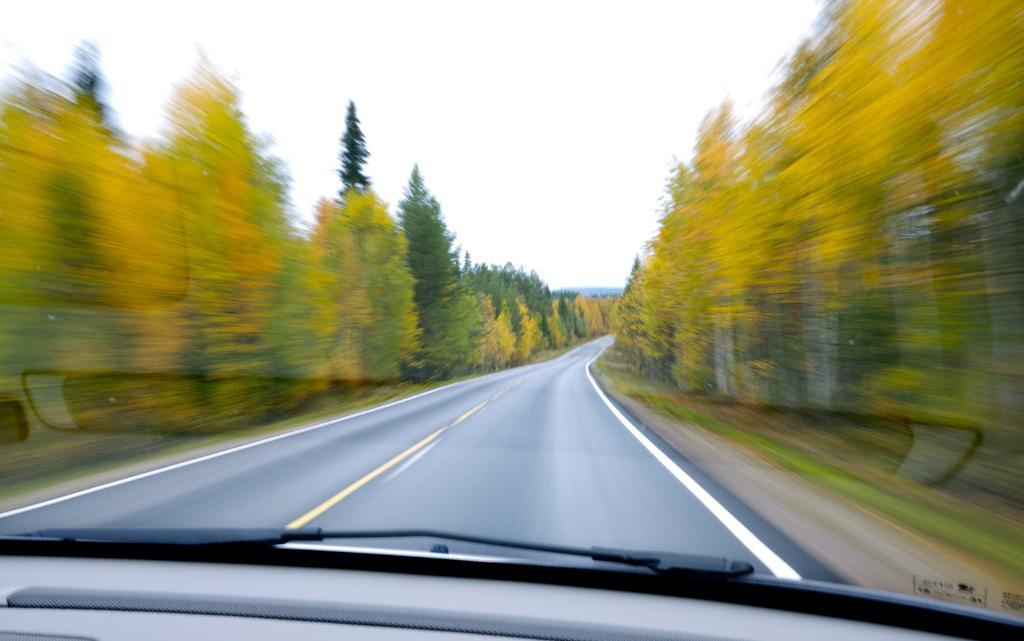What is the main subject of the image? The main subject of the image is a car on the road. What can be seen on the sides of the road in the image? There are trees on both the left and right sides of the image. What is visible at the top of the image? The sky is visible at the top of the image. What type of riddle does the manager ask in the image? There is no manager or riddle present in the image. What question does the car ask in the image? Cars do not ask questions, as they are inanimate objects. 